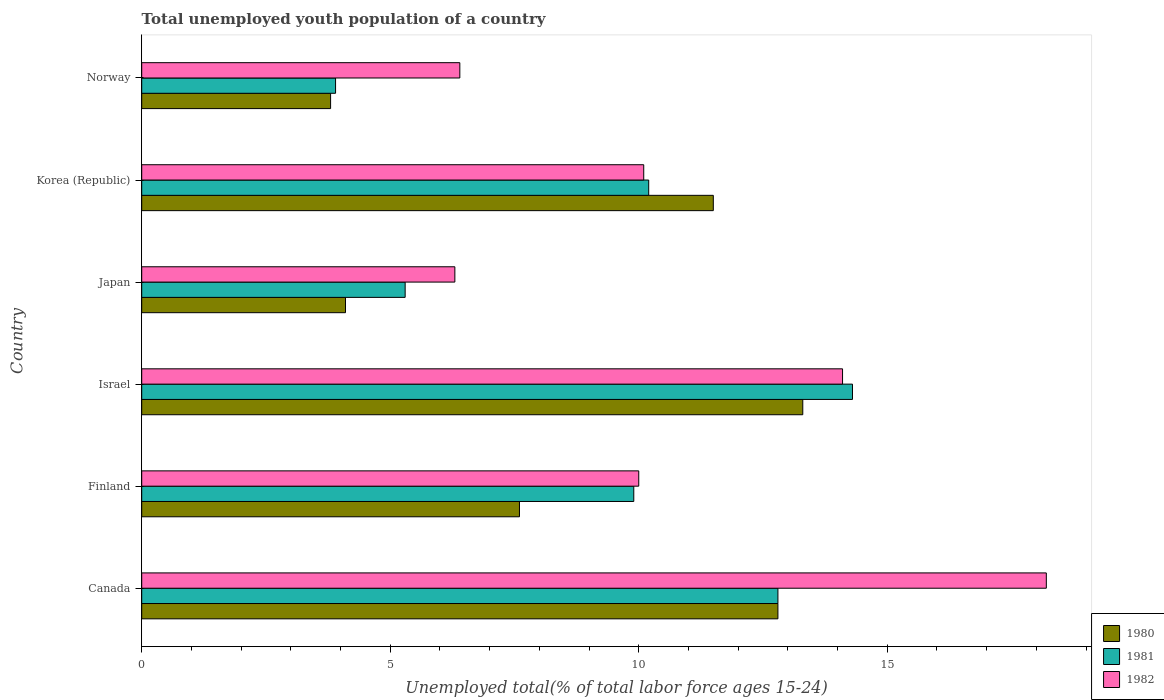How many different coloured bars are there?
Your answer should be very brief. 3. Are the number of bars per tick equal to the number of legend labels?
Offer a very short reply. Yes. Are the number of bars on each tick of the Y-axis equal?
Offer a very short reply. Yes. What is the label of the 4th group of bars from the top?
Provide a succinct answer. Israel. In how many cases, is the number of bars for a given country not equal to the number of legend labels?
Your answer should be compact. 0. What is the percentage of total unemployed youth population of a country in 1981 in Japan?
Your answer should be very brief. 5.3. Across all countries, what is the maximum percentage of total unemployed youth population of a country in 1980?
Give a very brief answer. 13.3. Across all countries, what is the minimum percentage of total unemployed youth population of a country in 1981?
Provide a succinct answer. 3.9. What is the total percentage of total unemployed youth population of a country in 1981 in the graph?
Your answer should be compact. 56.4. What is the difference between the percentage of total unemployed youth population of a country in 1982 in Japan and that in Korea (Republic)?
Keep it short and to the point. -3.8. What is the difference between the percentage of total unemployed youth population of a country in 1982 in Israel and the percentage of total unemployed youth population of a country in 1981 in Norway?
Make the answer very short. 10.2. What is the average percentage of total unemployed youth population of a country in 1982 per country?
Offer a terse response. 10.85. What is the difference between the percentage of total unemployed youth population of a country in 1982 and percentage of total unemployed youth population of a country in 1980 in Japan?
Offer a very short reply. 2.2. In how many countries, is the percentage of total unemployed youth population of a country in 1980 greater than 10 %?
Your answer should be compact. 3. What is the ratio of the percentage of total unemployed youth population of a country in 1980 in Finland to that in Norway?
Make the answer very short. 2. Is the percentage of total unemployed youth population of a country in 1980 in Canada less than that in Israel?
Your response must be concise. Yes. Is the difference between the percentage of total unemployed youth population of a country in 1982 in Finland and Israel greater than the difference between the percentage of total unemployed youth population of a country in 1980 in Finland and Israel?
Your answer should be compact. Yes. What is the difference between the highest and the second highest percentage of total unemployed youth population of a country in 1981?
Offer a very short reply. 1.5. What is the difference between the highest and the lowest percentage of total unemployed youth population of a country in 1982?
Offer a very short reply. 11.9. In how many countries, is the percentage of total unemployed youth population of a country in 1980 greater than the average percentage of total unemployed youth population of a country in 1980 taken over all countries?
Offer a terse response. 3. What does the 2nd bar from the bottom in Korea (Republic) represents?
Provide a short and direct response. 1981. Is it the case that in every country, the sum of the percentage of total unemployed youth population of a country in 1981 and percentage of total unemployed youth population of a country in 1982 is greater than the percentage of total unemployed youth population of a country in 1980?
Your response must be concise. Yes. Are all the bars in the graph horizontal?
Make the answer very short. Yes. How many countries are there in the graph?
Your answer should be very brief. 6. Are the values on the major ticks of X-axis written in scientific E-notation?
Offer a very short reply. No. How many legend labels are there?
Provide a succinct answer. 3. What is the title of the graph?
Ensure brevity in your answer.  Total unemployed youth population of a country. Does "2007" appear as one of the legend labels in the graph?
Keep it short and to the point. No. What is the label or title of the X-axis?
Make the answer very short. Unemployed total(% of total labor force ages 15-24). What is the label or title of the Y-axis?
Ensure brevity in your answer.  Country. What is the Unemployed total(% of total labor force ages 15-24) in 1980 in Canada?
Keep it short and to the point. 12.8. What is the Unemployed total(% of total labor force ages 15-24) in 1981 in Canada?
Ensure brevity in your answer.  12.8. What is the Unemployed total(% of total labor force ages 15-24) in 1982 in Canada?
Provide a short and direct response. 18.2. What is the Unemployed total(% of total labor force ages 15-24) in 1980 in Finland?
Provide a succinct answer. 7.6. What is the Unemployed total(% of total labor force ages 15-24) in 1981 in Finland?
Keep it short and to the point. 9.9. What is the Unemployed total(% of total labor force ages 15-24) of 1982 in Finland?
Provide a short and direct response. 10. What is the Unemployed total(% of total labor force ages 15-24) of 1980 in Israel?
Make the answer very short. 13.3. What is the Unemployed total(% of total labor force ages 15-24) of 1981 in Israel?
Your answer should be compact. 14.3. What is the Unemployed total(% of total labor force ages 15-24) in 1982 in Israel?
Keep it short and to the point. 14.1. What is the Unemployed total(% of total labor force ages 15-24) in 1980 in Japan?
Your answer should be very brief. 4.1. What is the Unemployed total(% of total labor force ages 15-24) in 1981 in Japan?
Your answer should be very brief. 5.3. What is the Unemployed total(% of total labor force ages 15-24) in 1982 in Japan?
Offer a very short reply. 6.3. What is the Unemployed total(% of total labor force ages 15-24) in 1980 in Korea (Republic)?
Provide a succinct answer. 11.5. What is the Unemployed total(% of total labor force ages 15-24) in 1981 in Korea (Republic)?
Make the answer very short. 10.2. What is the Unemployed total(% of total labor force ages 15-24) in 1982 in Korea (Republic)?
Provide a short and direct response. 10.1. What is the Unemployed total(% of total labor force ages 15-24) of 1980 in Norway?
Offer a terse response. 3.8. What is the Unemployed total(% of total labor force ages 15-24) of 1981 in Norway?
Provide a short and direct response. 3.9. What is the Unemployed total(% of total labor force ages 15-24) of 1982 in Norway?
Give a very brief answer. 6.4. Across all countries, what is the maximum Unemployed total(% of total labor force ages 15-24) in 1980?
Provide a short and direct response. 13.3. Across all countries, what is the maximum Unemployed total(% of total labor force ages 15-24) in 1981?
Your answer should be compact. 14.3. Across all countries, what is the maximum Unemployed total(% of total labor force ages 15-24) of 1982?
Give a very brief answer. 18.2. Across all countries, what is the minimum Unemployed total(% of total labor force ages 15-24) of 1980?
Offer a very short reply. 3.8. Across all countries, what is the minimum Unemployed total(% of total labor force ages 15-24) in 1981?
Provide a short and direct response. 3.9. Across all countries, what is the minimum Unemployed total(% of total labor force ages 15-24) in 1982?
Provide a succinct answer. 6.3. What is the total Unemployed total(% of total labor force ages 15-24) in 1980 in the graph?
Make the answer very short. 53.1. What is the total Unemployed total(% of total labor force ages 15-24) of 1981 in the graph?
Give a very brief answer. 56.4. What is the total Unemployed total(% of total labor force ages 15-24) in 1982 in the graph?
Offer a terse response. 65.1. What is the difference between the Unemployed total(% of total labor force ages 15-24) of 1980 in Canada and that in Finland?
Ensure brevity in your answer.  5.2. What is the difference between the Unemployed total(% of total labor force ages 15-24) in 1981 in Canada and that in Israel?
Ensure brevity in your answer.  -1.5. What is the difference between the Unemployed total(% of total labor force ages 15-24) in 1980 in Canada and that in Japan?
Your answer should be very brief. 8.7. What is the difference between the Unemployed total(% of total labor force ages 15-24) of 1981 in Canada and that in Japan?
Make the answer very short. 7.5. What is the difference between the Unemployed total(% of total labor force ages 15-24) of 1982 in Canada and that in Japan?
Give a very brief answer. 11.9. What is the difference between the Unemployed total(% of total labor force ages 15-24) in 1981 in Canada and that in Korea (Republic)?
Ensure brevity in your answer.  2.6. What is the difference between the Unemployed total(% of total labor force ages 15-24) in 1982 in Canada and that in Korea (Republic)?
Your response must be concise. 8.1. What is the difference between the Unemployed total(% of total labor force ages 15-24) in 1981 in Canada and that in Norway?
Make the answer very short. 8.9. What is the difference between the Unemployed total(% of total labor force ages 15-24) of 1982 in Finland and that in Israel?
Your response must be concise. -4.1. What is the difference between the Unemployed total(% of total labor force ages 15-24) of 1982 in Finland and that in Japan?
Provide a succinct answer. 3.7. What is the difference between the Unemployed total(% of total labor force ages 15-24) in 1980 in Finland and that in Korea (Republic)?
Your response must be concise. -3.9. What is the difference between the Unemployed total(% of total labor force ages 15-24) in 1981 in Finland and that in Korea (Republic)?
Make the answer very short. -0.3. What is the difference between the Unemployed total(% of total labor force ages 15-24) of 1982 in Finland and that in Korea (Republic)?
Your answer should be compact. -0.1. What is the difference between the Unemployed total(% of total labor force ages 15-24) of 1981 in Finland and that in Norway?
Offer a very short reply. 6. What is the difference between the Unemployed total(% of total labor force ages 15-24) in 1982 in Finland and that in Norway?
Make the answer very short. 3.6. What is the difference between the Unemployed total(% of total labor force ages 15-24) of 1981 in Israel and that in Japan?
Offer a terse response. 9. What is the difference between the Unemployed total(% of total labor force ages 15-24) in 1982 in Israel and that in Japan?
Make the answer very short. 7.8. What is the difference between the Unemployed total(% of total labor force ages 15-24) of 1981 in Israel and that in Norway?
Make the answer very short. 10.4. What is the difference between the Unemployed total(% of total labor force ages 15-24) of 1981 in Japan and that in Korea (Republic)?
Ensure brevity in your answer.  -4.9. What is the difference between the Unemployed total(% of total labor force ages 15-24) of 1982 in Japan and that in Korea (Republic)?
Your answer should be very brief. -3.8. What is the difference between the Unemployed total(% of total labor force ages 15-24) in 1980 in Japan and that in Norway?
Offer a very short reply. 0.3. What is the difference between the Unemployed total(% of total labor force ages 15-24) in 1980 in Korea (Republic) and that in Norway?
Ensure brevity in your answer.  7.7. What is the difference between the Unemployed total(% of total labor force ages 15-24) in 1980 in Canada and the Unemployed total(% of total labor force ages 15-24) in 1981 in Finland?
Give a very brief answer. 2.9. What is the difference between the Unemployed total(% of total labor force ages 15-24) in 1980 in Canada and the Unemployed total(% of total labor force ages 15-24) in 1982 in Finland?
Keep it short and to the point. 2.8. What is the difference between the Unemployed total(% of total labor force ages 15-24) in 1980 in Canada and the Unemployed total(% of total labor force ages 15-24) in 1981 in Israel?
Keep it short and to the point. -1.5. What is the difference between the Unemployed total(% of total labor force ages 15-24) of 1980 in Canada and the Unemployed total(% of total labor force ages 15-24) of 1982 in Israel?
Provide a succinct answer. -1.3. What is the difference between the Unemployed total(% of total labor force ages 15-24) in 1981 in Canada and the Unemployed total(% of total labor force ages 15-24) in 1982 in Israel?
Provide a short and direct response. -1.3. What is the difference between the Unemployed total(% of total labor force ages 15-24) of 1980 in Canada and the Unemployed total(% of total labor force ages 15-24) of 1981 in Japan?
Your response must be concise. 7.5. What is the difference between the Unemployed total(% of total labor force ages 15-24) of 1980 in Canada and the Unemployed total(% of total labor force ages 15-24) of 1982 in Japan?
Your answer should be compact. 6.5. What is the difference between the Unemployed total(% of total labor force ages 15-24) in 1981 in Canada and the Unemployed total(% of total labor force ages 15-24) in 1982 in Korea (Republic)?
Your answer should be compact. 2.7. What is the difference between the Unemployed total(% of total labor force ages 15-24) of 1980 in Canada and the Unemployed total(% of total labor force ages 15-24) of 1982 in Norway?
Your answer should be very brief. 6.4. What is the difference between the Unemployed total(% of total labor force ages 15-24) in 1981 in Canada and the Unemployed total(% of total labor force ages 15-24) in 1982 in Norway?
Make the answer very short. 6.4. What is the difference between the Unemployed total(% of total labor force ages 15-24) of 1980 in Finland and the Unemployed total(% of total labor force ages 15-24) of 1981 in Israel?
Make the answer very short. -6.7. What is the difference between the Unemployed total(% of total labor force ages 15-24) of 1980 in Finland and the Unemployed total(% of total labor force ages 15-24) of 1982 in Israel?
Provide a succinct answer. -6.5. What is the difference between the Unemployed total(% of total labor force ages 15-24) of 1981 in Finland and the Unemployed total(% of total labor force ages 15-24) of 1982 in Israel?
Make the answer very short. -4.2. What is the difference between the Unemployed total(% of total labor force ages 15-24) in 1980 in Finland and the Unemployed total(% of total labor force ages 15-24) in 1981 in Japan?
Your response must be concise. 2.3. What is the difference between the Unemployed total(% of total labor force ages 15-24) in 1981 in Finland and the Unemployed total(% of total labor force ages 15-24) in 1982 in Japan?
Your response must be concise. 3.6. What is the difference between the Unemployed total(% of total labor force ages 15-24) in 1980 in Finland and the Unemployed total(% of total labor force ages 15-24) in 1981 in Korea (Republic)?
Your answer should be very brief. -2.6. What is the difference between the Unemployed total(% of total labor force ages 15-24) in 1981 in Finland and the Unemployed total(% of total labor force ages 15-24) in 1982 in Korea (Republic)?
Make the answer very short. -0.2. What is the difference between the Unemployed total(% of total labor force ages 15-24) in 1980 in Finland and the Unemployed total(% of total labor force ages 15-24) in 1982 in Norway?
Provide a succinct answer. 1.2. What is the difference between the Unemployed total(% of total labor force ages 15-24) of 1980 in Israel and the Unemployed total(% of total labor force ages 15-24) of 1981 in Korea (Republic)?
Keep it short and to the point. 3.1. What is the difference between the Unemployed total(% of total labor force ages 15-24) of 1980 in Israel and the Unemployed total(% of total labor force ages 15-24) of 1982 in Korea (Republic)?
Offer a very short reply. 3.2. What is the difference between the Unemployed total(% of total labor force ages 15-24) of 1981 in Israel and the Unemployed total(% of total labor force ages 15-24) of 1982 in Korea (Republic)?
Your answer should be very brief. 4.2. What is the difference between the Unemployed total(% of total labor force ages 15-24) of 1981 in Israel and the Unemployed total(% of total labor force ages 15-24) of 1982 in Norway?
Your answer should be very brief. 7.9. What is the difference between the Unemployed total(% of total labor force ages 15-24) of 1980 in Japan and the Unemployed total(% of total labor force ages 15-24) of 1982 in Korea (Republic)?
Your answer should be very brief. -6. What is the difference between the Unemployed total(% of total labor force ages 15-24) of 1981 in Japan and the Unemployed total(% of total labor force ages 15-24) of 1982 in Korea (Republic)?
Offer a terse response. -4.8. What is the difference between the Unemployed total(% of total labor force ages 15-24) in 1980 in Japan and the Unemployed total(% of total labor force ages 15-24) in 1982 in Norway?
Provide a succinct answer. -2.3. What is the difference between the Unemployed total(% of total labor force ages 15-24) in 1981 in Japan and the Unemployed total(% of total labor force ages 15-24) in 1982 in Norway?
Your response must be concise. -1.1. What is the difference between the Unemployed total(% of total labor force ages 15-24) in 1981 in Korea (Republic) and the Unemployed total(% of total labor force ages 15-24) in 1982 in Norway?
Your answer should be very brief. 3.8. What is the average Unemployed total(% of total labor force ages 15-24) in 1980 per country?
Your answer should be very brief. 8.85. What is the average Unemployed total(% of total labor force ages 15-24) of 1982 per country?
Your answer should be compact. 10.85. What is the difference between the Unemployed total(% of total labor force ages 15-24) in 1981 and Unemployed total(% of total labor force ages 15-24) in 1982 in Canada?
Provide a succinct answer. -5.4. What is the difference between the Unemployed total(% of total labor force ages 15-24) in 1980 and Unemployed total(% of total labor force ages 15-24) in 1981 in Finland?
Give a very brief answer. -2.3. What is the difference between the Unemployed total(% of total labor force ages 15-24) in 1980 and Unemployed total(% of total labor force ages 15-24) in 1982 in Finland?
Give a very brief answer. -2.4. What is the difference between the Unemployed total(% of total labor force ages 15-24) of 1981 and Unemployed total(% of total labor force ages 15-24) of 1982 in Finland?
Your answer should be very brief. -0.1. What is the difference between the Unemployed total(% of total labor force ages 15-24) of 1980 and Unemployed total(% of total labor force ages 15-24) of 1981 in Israel?
Keep it short and to the point. -1. What is the difference between the Unemployed total(% of total labor force ages 15-24) of 1980 and Unemployed total(% of total labor force ages 15-24) of 1981 in Japan?
Keep it short and to the point. -1.2. What is the difference between the Unemployed total(% of total labor force ages 15-24) of 1981 and Unemployed total(% of total labor force ages 15-24) of 1982 in Japan?
Make the answer very short. -1. What is the difference between the Unemployed total(% of total labor force ages 15-24) in 1980 and Unemployed total(% of total labor force ages 15-24) in 1981 in Korea (Republic)?
Keep it short and to the point. 1.3. What is the difference between the Unemployed total(% of total labor force ages 15-24) in 1980 and Unemployed total(% of total labor force ages 15-24) in 1982 in Korea (Republic)?
Offer a terse response. 1.4. What is the difference between the Unemployed total(% of total labor force ages 15-24) in 1980 and Unemployed total(% of total labor force ages 15-24) in 1981 in Norway?
Provide a succinct answer. -0.1. What is the difference between the Unemployed total(% of total labor force ages 15-24) of 1980 and Unemployed total(% of total labor force ages 15-24) of 1982 in Norway?
Provide a short and direct response. -2.6. What is the ratio of the Unemployed total(% of total labor force ages 15-24) of 1980 in Canada to that in Finland?
Your response must be concise. 1.68. What is the ratio of the Unemployed total(% of total labor force ages 15-24) of 1981 in Canada to that in Finland?
Your answer should be very brief. 1.29. What is the ratio of the Unemployed total(% of total labor force ages 15-24) in 1982 in Canada to that in Finland?
Offer a terse response. 1.82. What is the ratio of the Unemployed total(% of total labor force ages 15-24) of 1980 in Canada to that in Israel?
Keep it short and to the point. 0.96. What is the ratio of the Unemployed total(% of total labor force ages 15-24) in 1981 in Canada to that in Israel?
Your response must be concise. 0.9. What is the ratio of the Unemployed total(% of total labor force ages 15-24) in 1982 in Canada to that in Israel?
Your answer should be very brief. 1.29. What is the ratio of the Unemployed total(% of total labor force ages 15-24) in 1980 in Canada to that in Japan?
Keep it short and to the point. 3.12. What is the ratio of the Unemployed total(% of total labor force ages 15-24) in 1981 in Canada to that in Japan?
Offer a terse response. 2.42. What is the ratio of the Unemployed total(% of total labor force ages 15-24) in 1982 in Canada to that in Japan?
Keep it short and to the point. 2.89. What is the ratio of the Unemployed total(% of total labor force ages 15-24) of 1980 in Canada to that in Korea (Republic)?
Your answer should be compact. 1.11. What is the ratio of the Unemployed total(% of total labor force ages 15-24) in 1981 in Canada to that in Korea (Republic)?
Offer a terse response. 1.25. What is the ratio of the Unemployed total(% of total labor force ages 15-24) in 1982 in Canada to that in Korea (Republic)?
Provide a succinct answer. 1.8. What is the ratio of the Unemployed total(% of total labor force ages 15-24) of 1980 in Canada to that in Norway?
Offer a very short reply. 3.37. What is the ratio of the Unemployed total(% of total labor force ages 15-24) in 1981 in Canada to that in Norway?
Offer a very short reply. 3.28. What is the ratio of the Unemployed total(% of total labor force ages 15-24) of 1982 in Canada to that in Norway?
Give a very brief answer. 2.84. What is the ratio of the Unemployed total(% of total labor force ages 15-24) of 1980 in Finland to that in Israel?
Give a very brief answer. 0.57. What is the ratio of the Unemployed total(% of total labor force ages 15-24) of 1981 in Finland to that in Israel?
Your answer should be very brief. 0.69. What is the ratio of the Unemployed total(% of total labor force ages 15-24) in 1982 in Finland to that in Israel?
Give a very brief answer. 0.71. What is the ratio of the Unemployed total(% of total labor force ages 15-24) of 1980 in Finland to that in Japan?
Give a very brief answer. 1.85. What is the ratio of the Unemployed total(% of total labor force ages 15-24) of 1981 in Finland to that in Japan?
Make the answer very short. 1.87. What is the ratio of the Unemployed total(% of total labor force ages 15-24) in 1982 in Finland to that in Japan?
Your response must be concise. 1.59. What is the ratio of the Unemployed total(% of total labor force ages 15-24) of 1980 in Finland to that in Korea (Republic)?
Your answer should be compact. 0.66. What is the ratio of the Unemployed total(% of total labor force ages 15-24) in 1981 in Finland to that in Korea (Republic)?
Ensure brevity in your answer.  0.97. What is the ratio of the Unemployed total(% of total labor force ages 15-24) of 1980 in Finland to that in Norway?
Make the answer very short. 2. What is the ratio of the Unemployed total(% of total labor force ages 15-24) in 1981 in Finland to that in Norway?
Your answer should be very brief. 2.54. What is the ratio of the Unemployed total(% of total labor force ages 15-24) in 1982 in Finland to that in Norway?
Your answer should be compact. 1.56. What is the ratio of the Unemployed total(% of total labor force ages 15-24) in 1980 in Israel to that in Japan?
Offer a very short reply. 3.24. What is the ratio of the Unemployed total(% of total labor force ages 15-24) in 1981 in Israel to that in Japan?
Make the answer very short. 2.7. What is the ratio of the Unemployed total(% of total labor force ages 15-24) in 1982 in Israel to that in Japan?
Provide a succinct answer. 2.24. What is the ratio of the Unemployed total(% of total labor force ages 15-24) of 1980 in Israel to that in Korea (Republic)?
Your answer should be compact. 1.16. What is the ratio of the Unemployed total(% of total labor force ages 15-24) in 1981 in Israel to that in Korea (Republic)?
Your answer should be very brief. 1.4. What is the ratio of the Unemployed total(% of total labor force ages 15-24) in 1982 in Israel to that in Korea (Republic)?
Keep it short and to the point. 1.4. What is the ratio of the Unemployed total(% of total labor force ages 15-24) of 1981 in Israel to that in Norway?
Make the answer very short. 3.67. What is the ratio of the Unemployed total(% of total labor force ages 15-24) of 1982 in Israel to that in Norway?
Provide a succinct answer. 2.2. What is the ratio of the Unemployed total(% of total labor force ages 15-24) of 1980 in Japan to that in Korea (Republic)?
Offer a very short reply. 0.36. What is the ratio of the Unemployed total(% of total labor force ages 15-24) of 1981 in Japan to that in Korea (Republic)?
Offer a terse response. 0.52. What is the ratio of the Unemployed total(% of total labor force ages 15-24) in 1982 in Japan to that in Korea (Republic)?
Your answer should be compact. 0.62. What is the ratio of the Unemployed total(% of total labor force ages 15-24) of 1980 in Japan to that in Norway?
Make the answer very short. 1.08. What is the ratio of the Unemployed total(% of total labor force ages 15-24) in 1981 in Japan to that in Norway?
Provide a succinct answer. 1.36. What is the ratio of the Unemployed total(% of total labor force ages 15-24) in 1982 in Japan to that in Norway?
Provide a short and direct response. 0.98. What is the ratio of the Unemployed total(% of total labor force ages 15-24) in 1980 in Korea (Republic) to that in Norway?
Ensure brevity in your answer.  3.03. What is the ratio of the Unemployed total(% of total labor force ages 15-24) in 1981 in Korea (Republic) to that in Norway?
Provide a short and direct response. 2.62. What is the ratio of the Unemployed total(% of total labor force ages 15-24) in 1982 in Korea (Republic) to that in Norway?
Give a very brief answer. 1.58. What is the difference between the highest and the second highest Unemployed total(% of total labor force ages 15-24) in 1981?
Your answer should be compact. 1.5. What is the difference between the highest and the second highest Unemployed total(% of total labor force ages 15-24) in 1982?
Offer a terse response. 4.1. What is the difference between the highest and the lowest Unemployed total(% of total labor force ages 15-24) of 1980?
Provide a short and direct response. 9.5. What is the difference between the highest and the lowest Unemployed total(% of total labor force ages 15-24) in 1981?
Offer a very short reply. 10.4. What is the difference between the highest and the lowest Unemployed total(% of total labor force ages 15-24) in 1982?
Offer a very short reply. 11.9. 